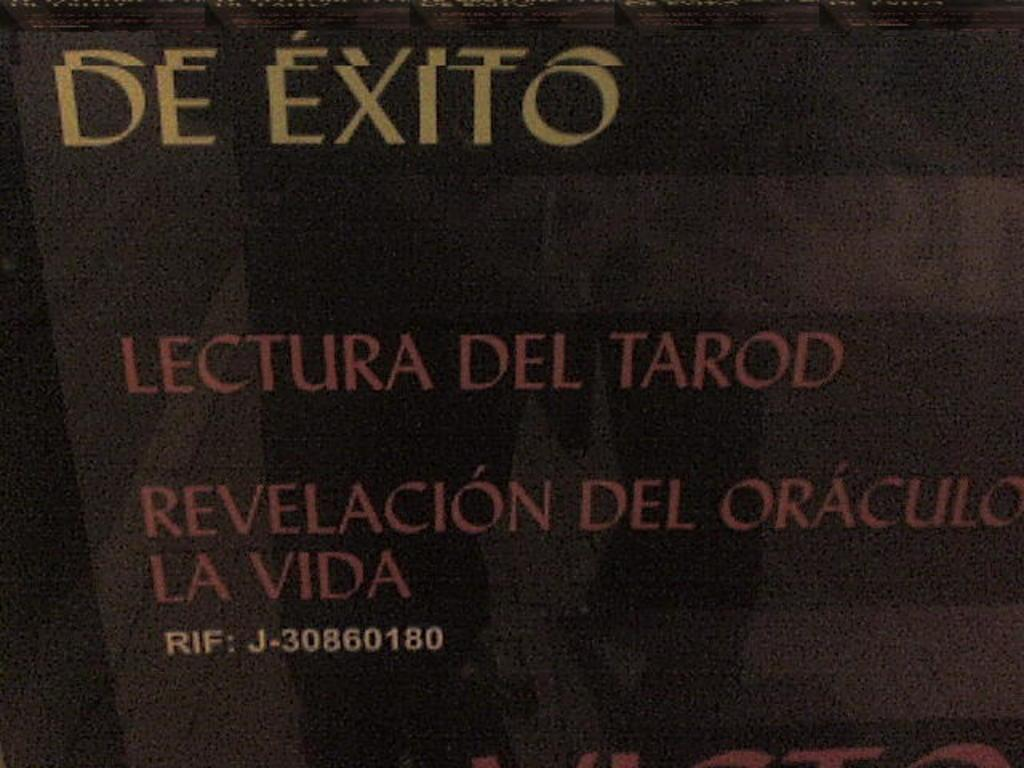<image>
Describe the image concisely. A black sign is marked "de exito" in white letters. 